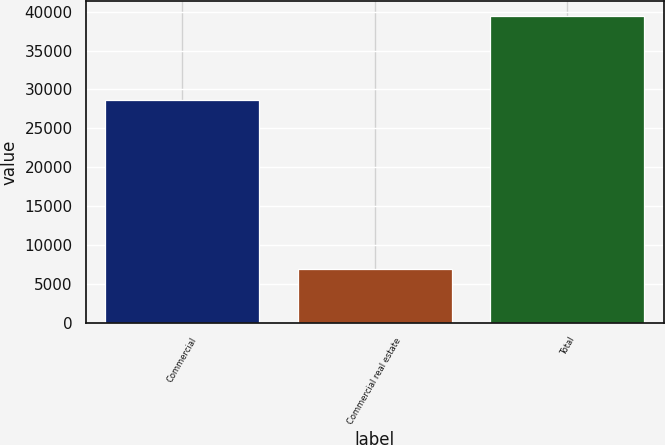Convert chart. <chart><loc_0><loc_0><loc_500><loc_500><bar_chart><fcel>Commercial<fcel>Commercial real estate<fcel>Total<nl><fcel>28667<fcel>6948<fcel>39395<nl></chart> 